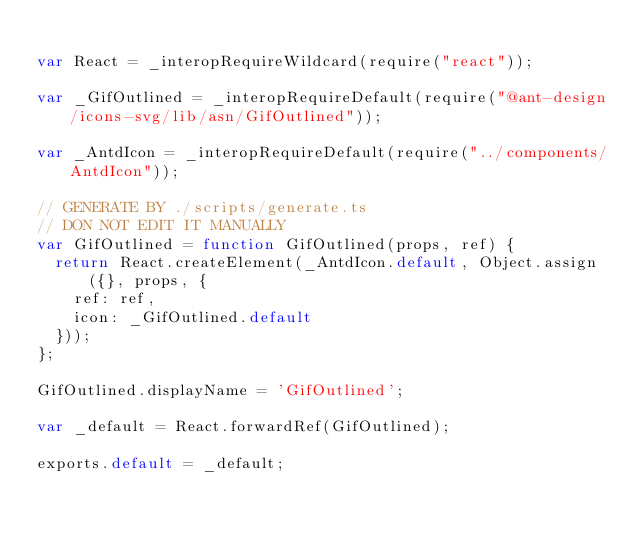<code> <loc_0><loc_0><loc_500><loc_500><_JavaScript_>
var React = _interopRequireWildcard(require("react"));

var _GifOutlined = _interopRequireDefault(require("@ant-design/icons-svg/lib/asn/GifOutlined"));

var _AntdIcon = _interopRequireDefault(require("../components/AntdIcon"));

// GENERATE BY ./scripts/generate.ts
// DON NOT EDIT IT MANUALLY
var GifOutlined = function GifOutlined(props, ref) {
  return React.createElement(_AntdIcon.default, Object.assign({}, props, {
    ref: ref,
    icon: _GifOutlined.default
  }));
};

GifOutlined.displayName = 'GifOutlined';

var _default = React.forwardRef(GifOutlined);

exports.default = _default;</code> 